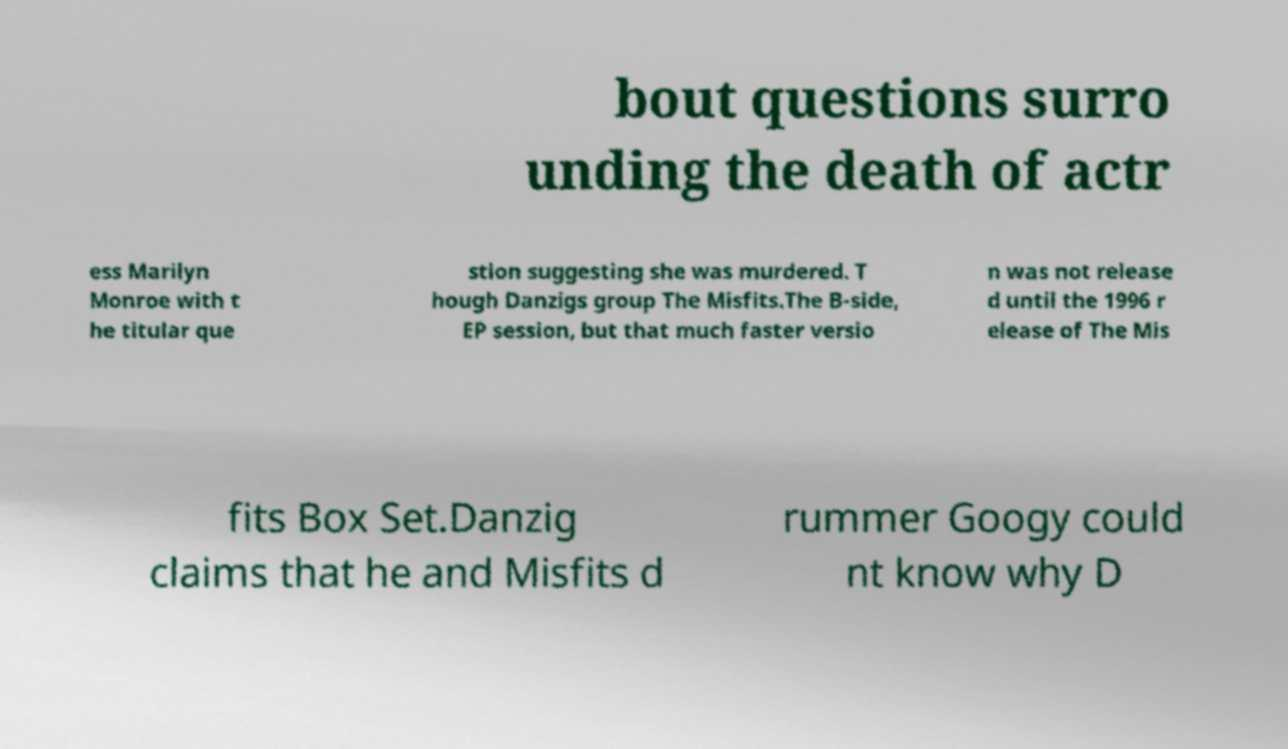Please read and relay the text visible in this image. What does it say? bout questions surro unding the death of actr ess Marilyn Monroe with t he titular que stion suggesting she was murdered. T hough Danzigs group The Misfits.The B-side, EP session, but that much faster versio n was not release d until the 1996 r elease of The Mis fits Box Set.Danzig claims that he and Misfits d rummer Googy could nt know why D 